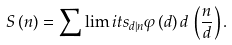Convert formula to latex. <formula><loc_0><loc_0><loc_500><loc_500>S \, ( n ) = \sum \lim i t s _ { d | n } \varphi \, ( d ) \, d \, \left ( \frac { n } { d } \right ) .</formula> 